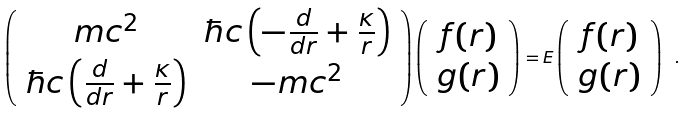Convert formula to latex. <formula><loc_0><loc_0><loc_500><loc_500>\left ( \begin{array} { c c } m c ^ { 2 } & \hbar { c } \left ( - \frac { d } { d r } + \frac { \kappa } { r } \right ) \\ \hbar { c } \left ( \frac { d } { d r } + \frac { \kappa } { r } \right ) & - m c ^ { 2 } \end{array} \right ) \left ( \begin{array} { c } f ( r ) \\ g ( r ) \end{array} \right ) = E \left ( \begin{array} { c } f ( r ) \\ g ( r ) \end{array} \right ) \ .</formula> 